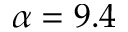<formula> <loc_0><loc_0><loc_500><loc_500>\alpha = 9 . 4</formula> 